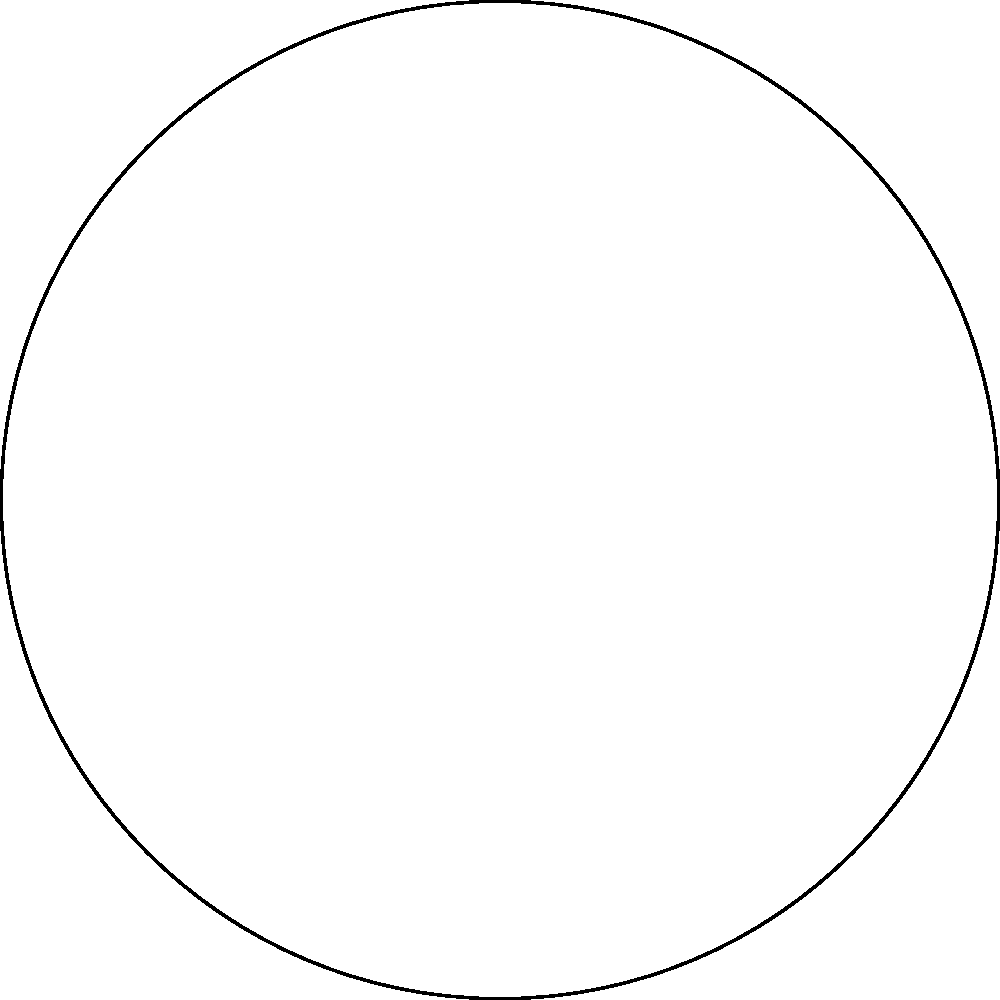In the Poincaré disk model shown above, three cameras are positioned at points A, B, and C to capture a dramatic scene for a reality TV show. The hyperbolic lines connecting these points represent potential camera angles. Which camera position would provide the most unique perspective, maximizing the non-Euclidean distortion effect for heightened drama? To determine which camera position provides the most unique perspective with maximum non-Euclidean distortion, we need to consider the following steps:

1. Understand the Poincaré disk model:
   - The disk represents an infinite hyperbolic plane.
   - Straight lines in hyperbolic geometry appear as circular arcs perpendicular to the disk's boundary.

2. Analyze the camera positions:
   - Camera 1 (A): (0.5, 0.3) - relatively close to the center
   - Camera 2 (B): (-0.4, -0.6) - closer to the edge
   - Camera 3 (C): (0.2, -0.7) - closest to the edge

3. Consider the distortion effect:
   - In the Poincaré disk model, distortion increases as we move towards the edge of the disk.
   - Objects appear to shrink and compress as they approach the boundary.

4. Evaluate the hyperbolic lines:
   - The blue line (AB) has the least curvature.
   - The red line (BC) and green line (CA) have more pronounced curvature.

5. Assess the dramatic effect:
   - Camera positions closer to the edge will capture more distorted and unique perspectives.
   - The camera closest to the boundary will provide the most exaggerated non-Euclidean effect.

6. Conclusion:
   Camera 3 (C) is positioned closest to the edge of the disk, which means it will capture the most distorted and unique perspective, maximizing the non-Euclidean effect for heightened drama in the reality TV show scene.
Answer: Camera 3 (C) 